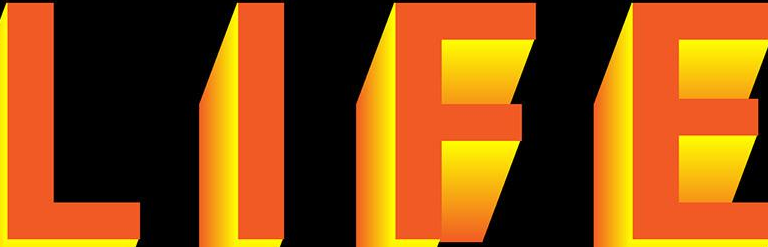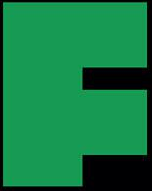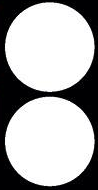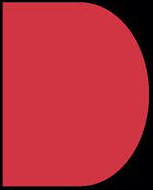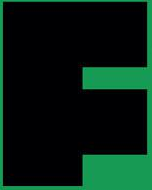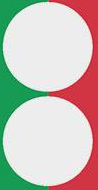What text is displayed in these images sequentially, separated by a semicolon? LIFE; F; :; D; F; : 